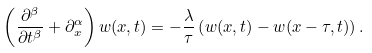Convert formula to latex. <formula><loc_0><loc_0><loc_500><loc_500>\left ( \frac { \partial ^ { \beta } } { \partial t ^ { \beta } } + \partial ^ { \alpha } _ { x } \right ) w ( x , t ) = - \frac { \lambda } { \tau } \left ( w ( x , t ) - w ( x - \tau , t ) \right ) .</formula> 